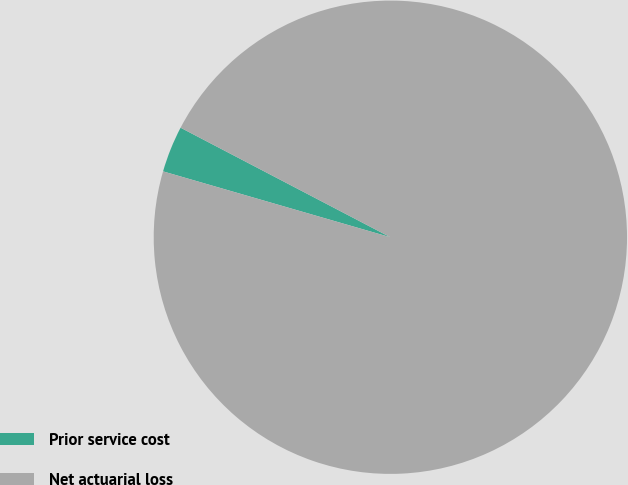Convert chart to OTSL. <chart><loc_0><loc_0><loc_500><loc_500><pie_chart><fcel>Prior service cost<fcel>Net actuarial loss<nl><fcel>3.17%<fcel>96.83%<nl></chart> 